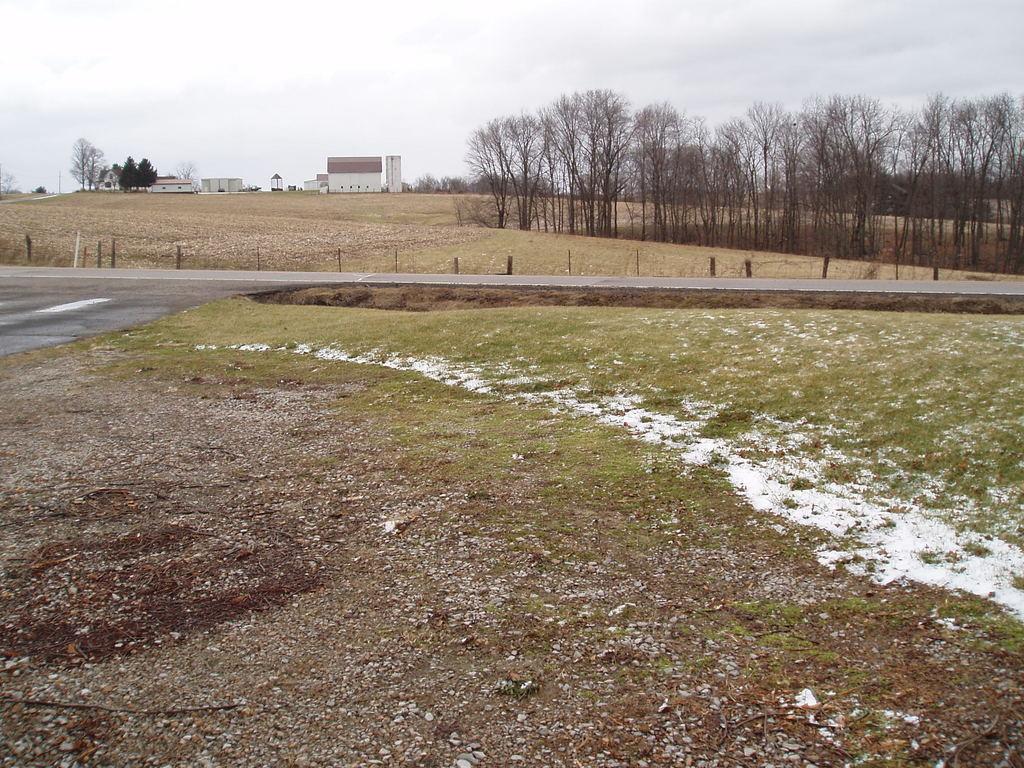Could you give a brief overview of what you see in this image? This is an outside view. In the middle of the image there is a road. On the both sides of this road I can see the grass in green color. In the background there are some buildings and the trees. On the top of the image I can see the sky. 